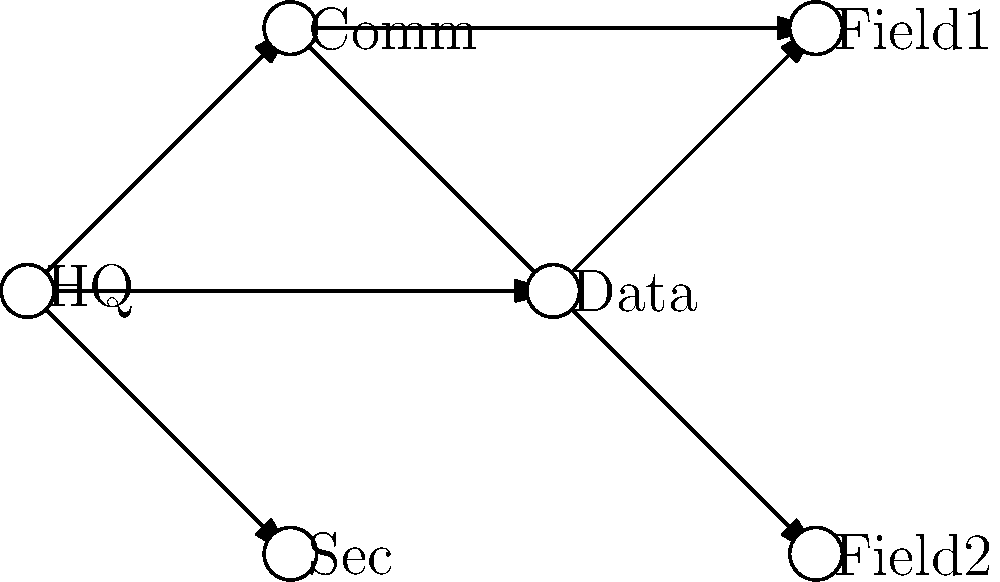In the given military network infrastructure schematic, which node represents the most critical point of failure that could potentially compromise the entire network's security and communication capabilities? To determine the most critical point of failure in this military network infrastructure, we need to analyze the topology and connections:

1. HQ (Headquarters) is connected to Comm (Communications), Data, and Sec (Security) nodes.
2. Comm node is connected to Field1 and Field2.
3. Data node is also connected to Field1 and Field2.
4. Sec node has no outgoing connections.

Step-by-step analysis:
1. If Field1 or Field2 fail, it only affects that specific field unit.
2. If Sec fails, it might compromise security but doesn't directly affect communication flow.
3. If Data fails, field units lose access to centralized data, but communication is still possible.
4. If Comm fails, field units lose direct communication with HQ.
5. If HQ fails, it disconnects all other nodes from the central command and control.

The HQ node is the most critical point because:
a) It's the central hub connecting all other primary nodes (Comm, Data, Sec).
b) Its failure would isolate all other nodes from each other.
c) It likely contains the most sensitive information and control systems.

Therefore, the HQ node represents the single point of failure that could potentially compromise the entire network's security and communication capabilities.
Answer: HQ (Headquarters) 